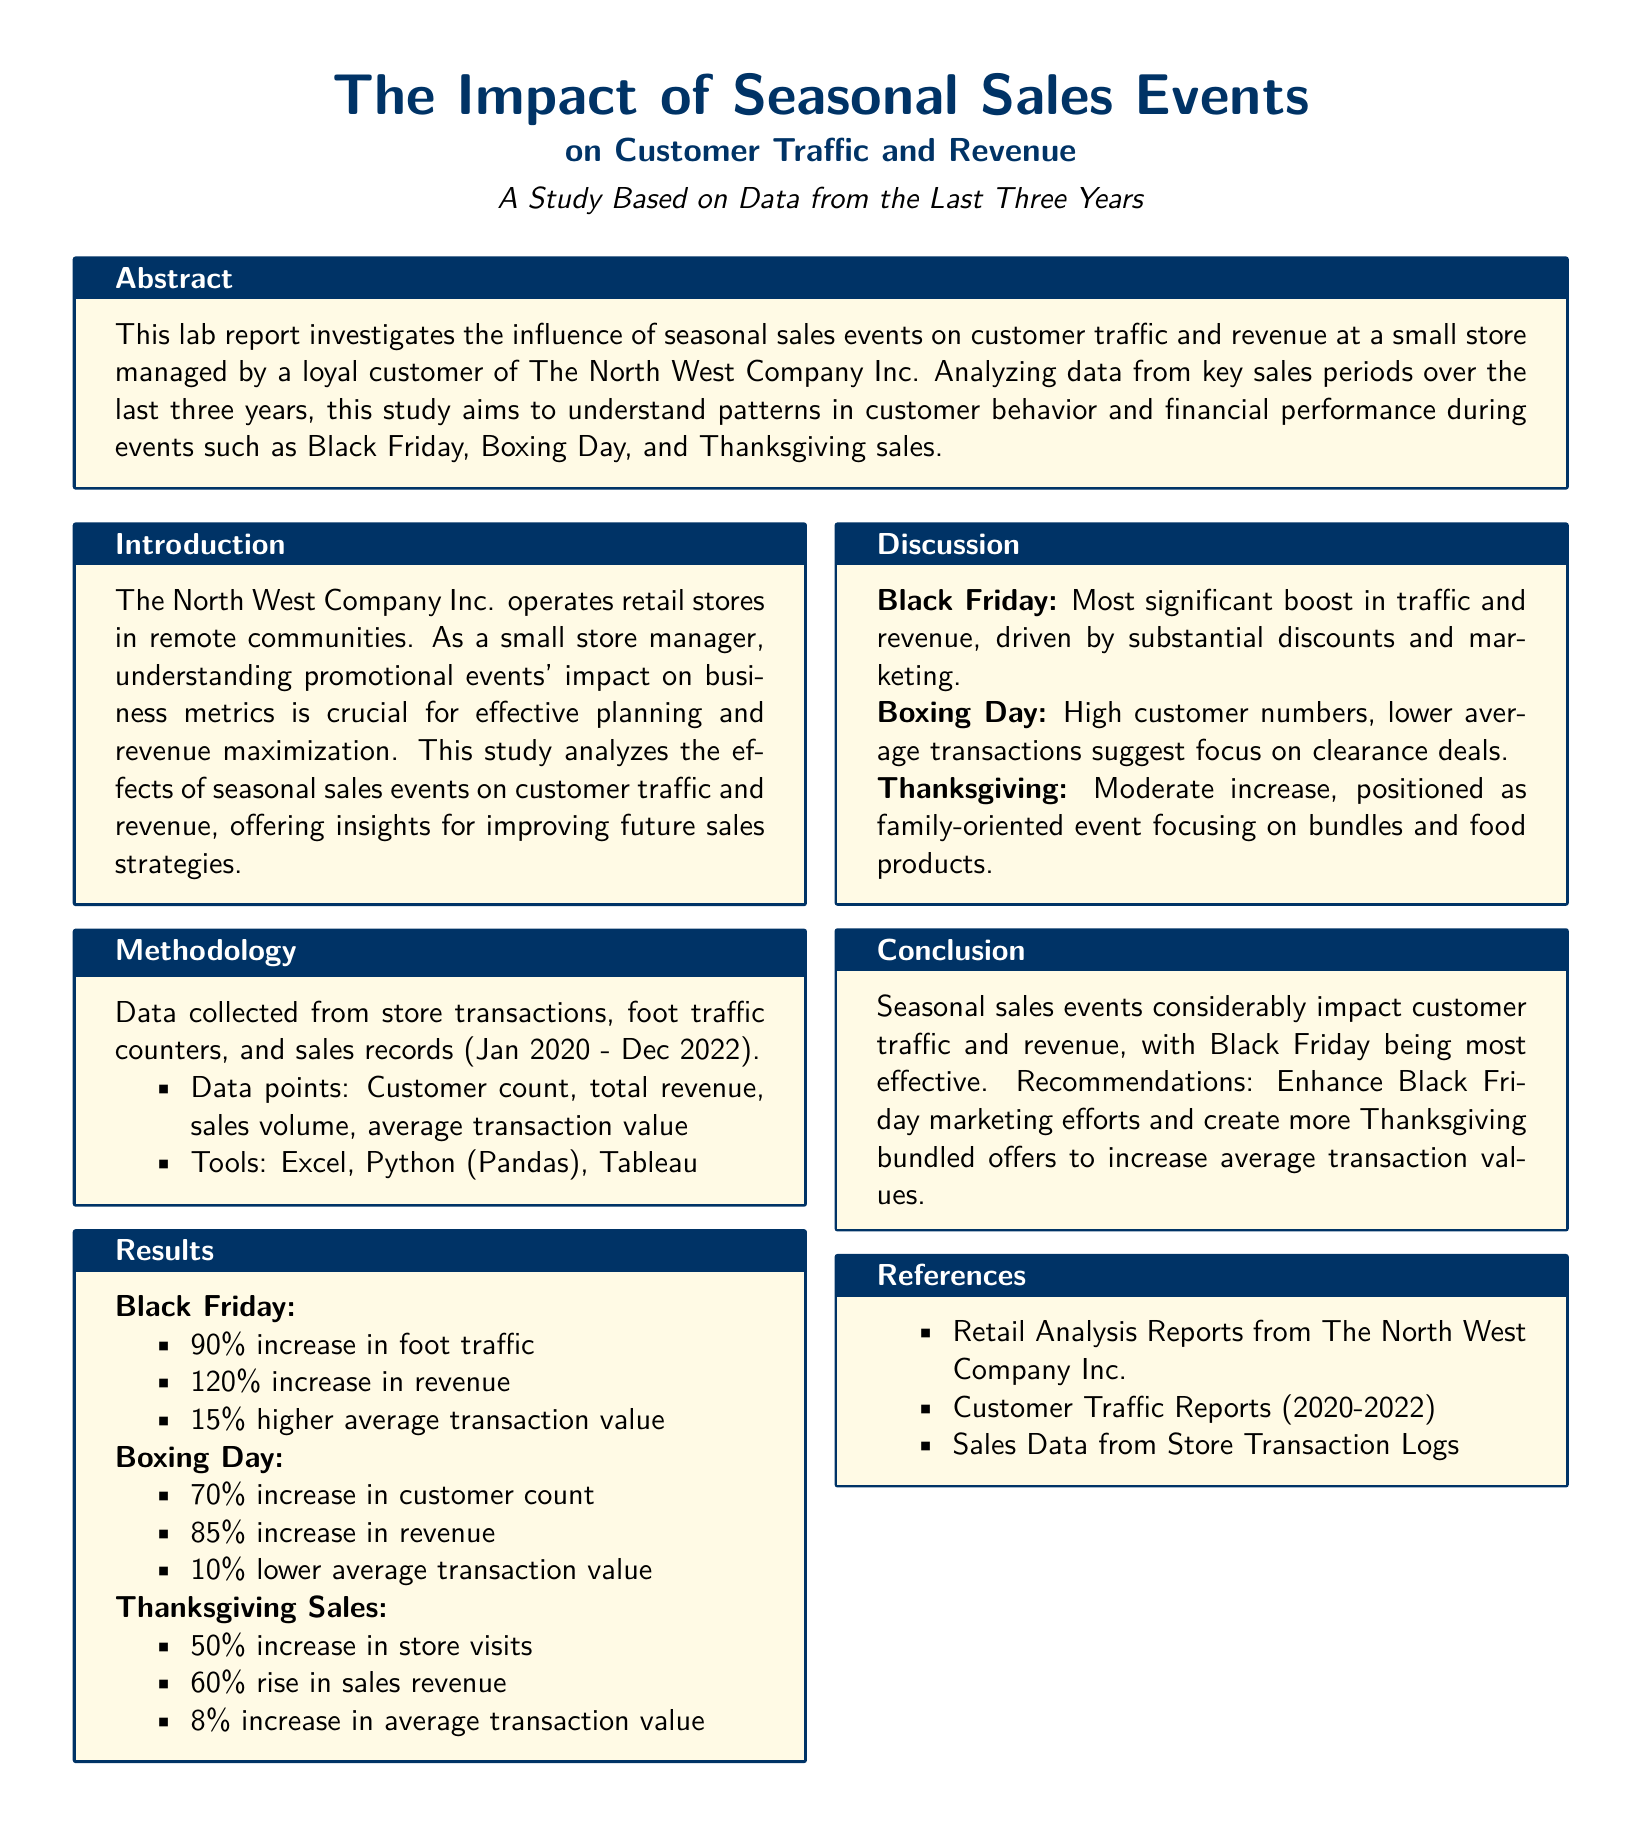What is the focus of the study? The focus of the study is to investigate the influence of seasonal sales events on customer traffic and revenue.
Answer: Influence of seasonal sales events on customer traffic and revenue What year range is the data collected from? The data is collected from the years 2020 to 2022.
Answer: 2020 to 2022 What was the increase in foot traffic on Black Friday? The report states a 90% increase in foot traffic during Black Friday.
Answer: 90% What does the analysis of Boxing Day show about average transaction value? The analysis indicates a 10% lower average transaction value during Boxing Day sales.
Answer: 10% lower Which seasonal sales event had the most significant boost in traffic and revenue? The study highlights that Black Friday had the most significant boost in traffic and revenue.
Answer: Black Friday What is a recommendation made in the conclusion? A recommendation made is to enhance Black Friday marketing efforts.
Answer: Enhance Black Friday marketing efforts What type of data was analyzed for the study? The data analyzed included customer count, total revenue, sales volume, and average transaction value.
Answer: Customer count, total revenue, sales volume, average transaction value What was the percentage increase in revenue during Thanksgiving sales? The revenue increase during Thanksgiving sales was reported as 60%.
Answer: 60% What does the discussion suggest about customer behavior during Boxing Day? The discussion suggests a focus on clearance deals by customers during Boxing Day.
Answer: Focus on clearance deals 